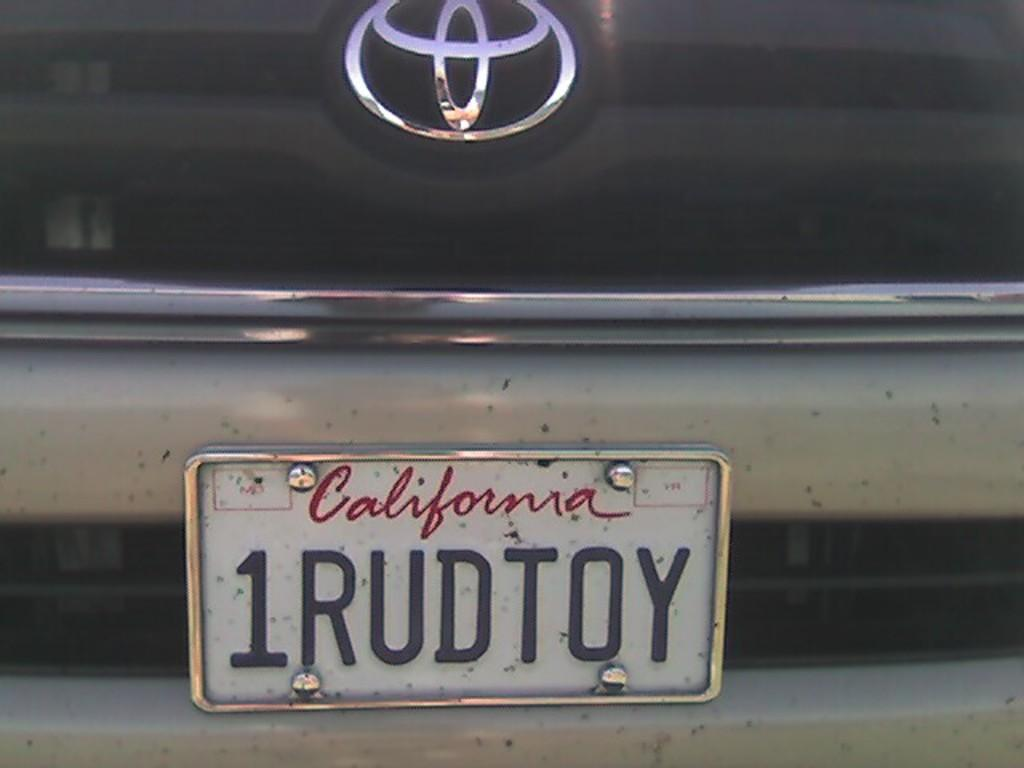<image>
Provide a brief description of the given image. A Toyota has a California license plate with the number 1RUDTOY. 